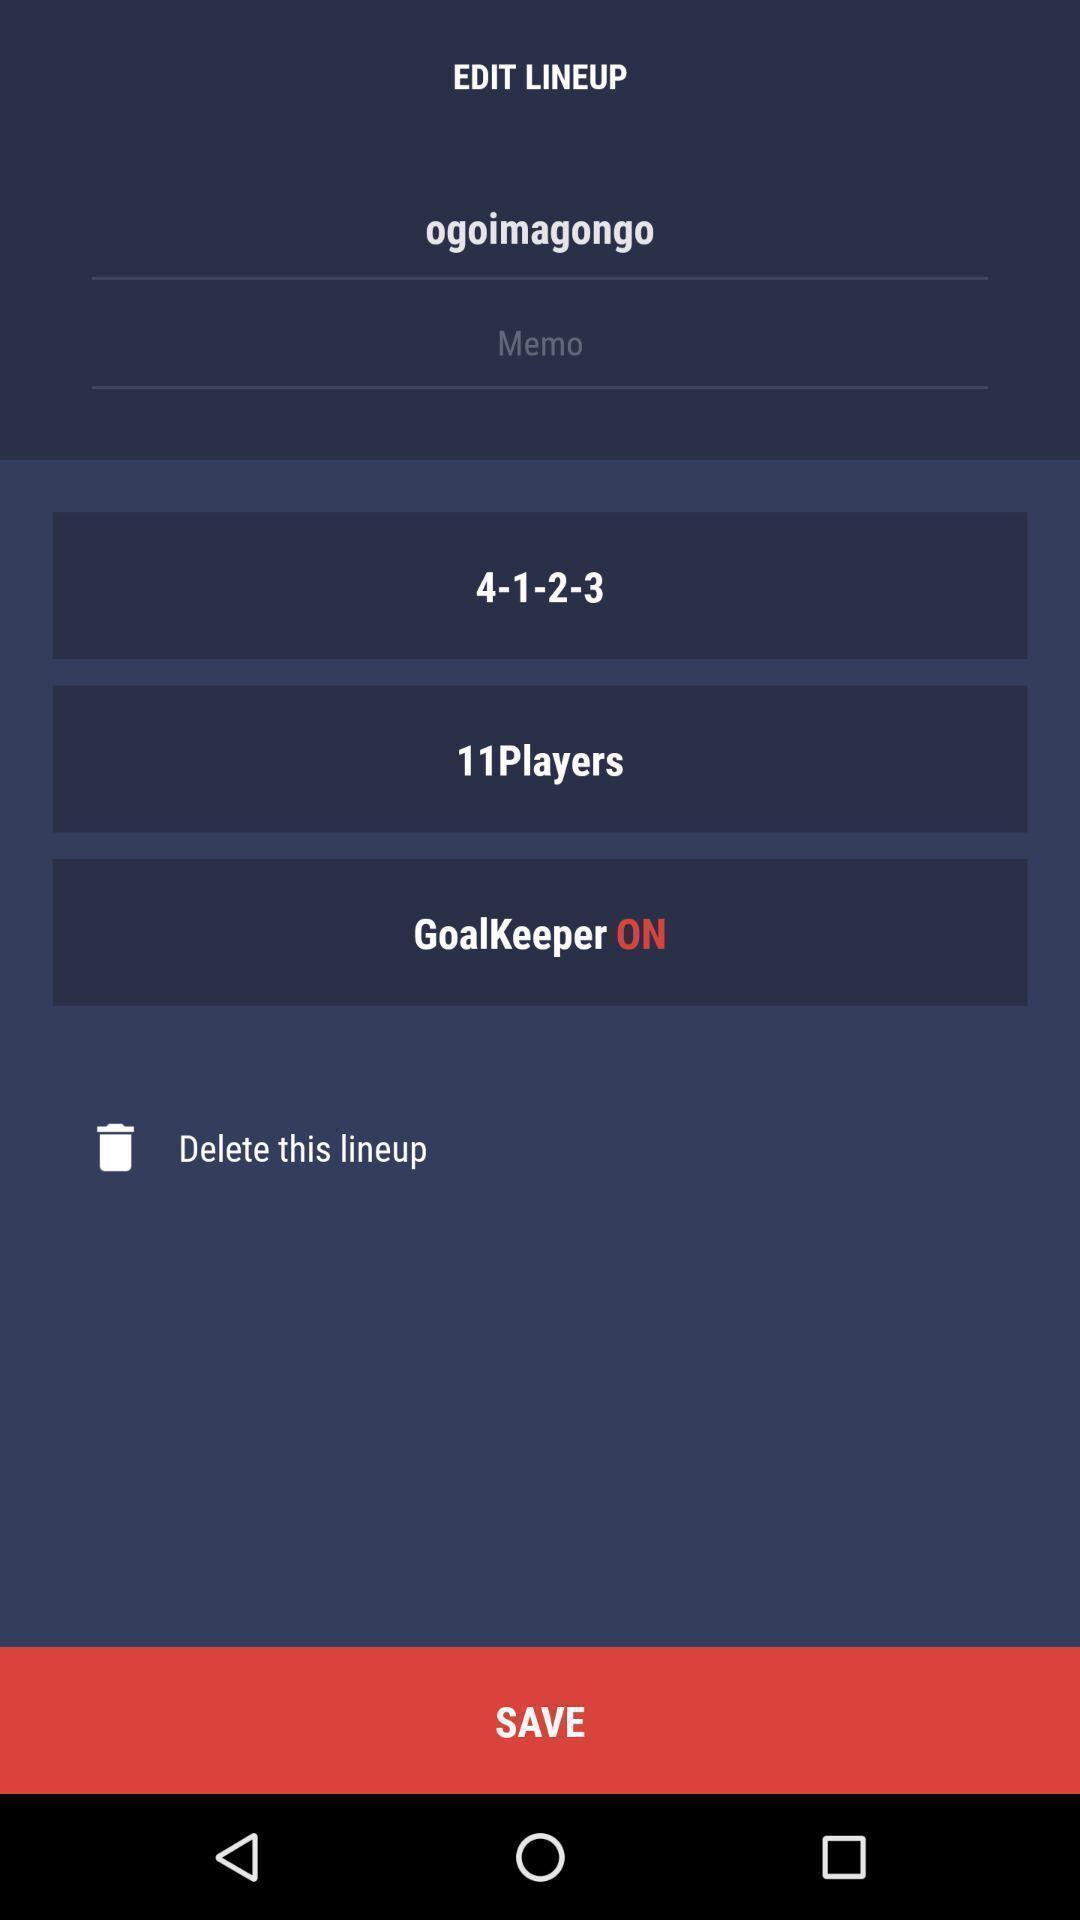Describe the content in this image. Page displaying the info of a team. 